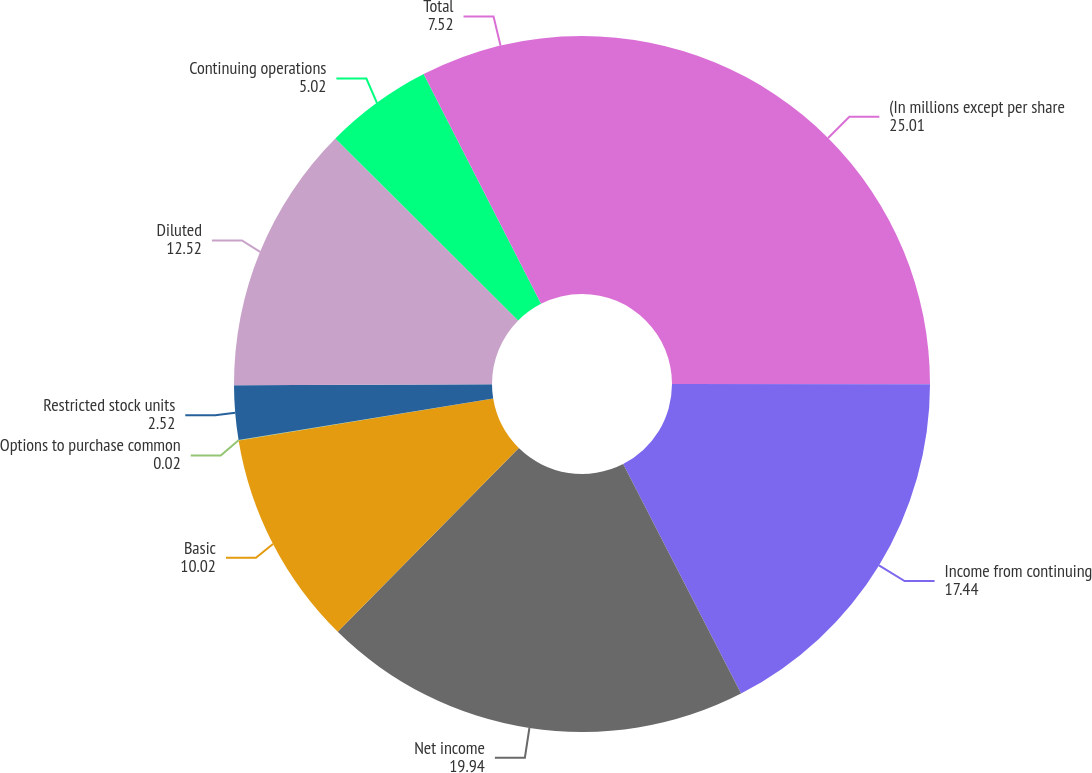Convert chart to OTSL. <chart><loc_0><loc_0><loc_500><loc_500><pie_chart><fcel>(In millions except per share<fcel>Income from continuing<fcel>Net income<fcel>Basic<fcel>Options to purchase common<fcel>Restricted stock units<fcel>Diluted<fcel>Continuing operations<fcel>Total<nl><fcel>25.01%<fcel>17.44%<fcel>19.94%<fcel>10.02%<fcel>0.02%<fcel>2.52%<fcel>12.52%<fcel>5.02%<fcel>7.52%<nl></chart> 